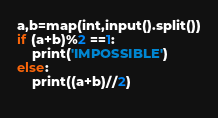Convert code to text. <code><loc_0><loc_0><loc_500><loc_500><_Python_>a,b=map(int,input().split())
if (a+b)%2 ==1:
    print('IMPOSSIBLE')
else:
    print((a+b)//2)
    </code> 